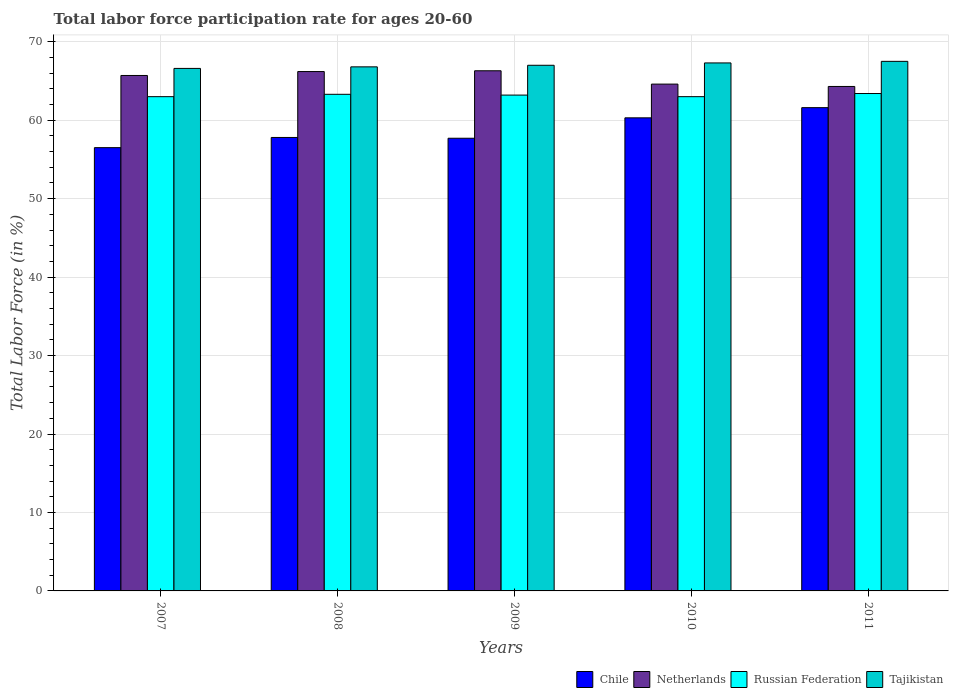How many different coloured bars are there?
Provide a succinct answer. 4. Are the number of bars per tick equal to the number of legend labels?
Your answer should be very brief. Yes. Are the number of bars on each tick of the X-axis equal?
Provide a succinct answer. Yes. What is the labor force participation rate in Netherlands in 2008?
Offer a very short reply. 66.2. Across all years, what is the maximum labor force participation rate in Chile?
Your answer should be compact. 61.6. Across all years, what is the minimum labor force participation rate in Tajikistan?
Give a very brief answer. 66.6. In which year was the labor force participation rate in Russian Federation maximum?
Give a very brief answer. 2011. In which year was the labor force participation rate in Netherlands minimum?
Offer a terse response. 2011. What is the total labor force participation rate in Netherlands in the graph?
Provide a succinct answer. 327.1. What is the difference between the labor force participation rate in Chile in 2010 and that in 2011?
Ensure brevity in your answer.  -1.3. What is the difference between the labor force participation rate in Netherlands in 2007 and the labor force participation rate in Chile in 2008?
Ensure brevity in your answer.  7.9. What is the average labor force participation rate in Russian Federation per year?
Offer a terse response. 63.18. In the year 2007, what is the difference between the labor force participation rate in Netherlands and labor force participation rate in Tajikistan?
Your response must be concise. -0.9. In how many years, is the labor force participation rate in Netherlands greater than 32 %?
Give a very brief answer. 5. What is the ratio of the labor force participation rate in Netherlands in 2007 to that in 2008?
Offer a very short reply. 0.99. What is the difference between the highest and the second highest labor force participation rate in Chile?
Keep it short and to the point. 1.3. In how many years, is the labor force participation rate in Russian Federation greater than the average labor force participation rate in Russian Federation taken over all years?
Offer a very short reply. 3. Is it the case that in every year, the sum of the labor force participation rate in Chile and labor force participation rate in Tajikistan is greater than the sum of labor force participation rate in Russian Federation and labor force participation rate in Netherlands?
Make the answer very short. No. What does the 3rd bar from the left in 2011 represents?
Provide a succinct answer. Russian Federation. What does the 2nd bar from the right in 2008 represents?
Offer a terse response. Russian Federation. Is it the case that in every year, the sum of the labor force participation rate in Chile and labor force participation rate in Russian Federation is greater than the labor force participation rate in Tajikistan?
Your response must be concise. Yes. How many bars are there?
Keep it short and to the point. 20. Are all the bars in the graph horizontal?
Ensure brevity in your answer.  No. Are the values on the major ticks of Y-axis written in scientific E-notation?
Offer a terse response. No. Does the graph contain any zero values?
Provide a short and direct response. No. Where does the legend appear in the graph?
Your response must be concise. Bottom right. How many legend labels are there?
Keep it short and to the point. 4. How are the legend labels stacked?
Provide a succinct answer. Horizontal. What is the title of the graph?
Make the answer very short. Total labor force participation rate for ages 20-60. Does "Equatorial Guinea" appear as one of the legend labels in the graph?
Offer a very short reply. No. What is the label or title of the X-axis?
Ensure brevity in your answer.  Years. What is the Total Labor Force (in %) in Chile in 2007?
Provide a succinct answer. 56.5. What is the Total Labor Force (in %) in Netherlands in 2007?
Keep it short and to the point. 65.7. What is the Total Labor Force (in %) of Tajikistan in 2007?
Your answer should be compact. 66.6. What is the Total Labor Force (in %) of Chile in 2008?
Offer a terse response. 57.8. What is the Total Labor Force (in %) of Netherlands in 2008?
Give a very brief answer. 66.2. What is the Total Labor Force (in %) of Russian Federation in 2008?
Make the answer very short. 63.3. What is the Total Labor Force (in %) of Tajikistan in 2008?
Make the answer very short. 66.8. What is the Total Labor Force (in %) of Chile in 2009?
Offer a terse response. 57.7. What is the Total Labor Force (in %) in Netherlands in 2009?
Offer a terse response. 66.3. What is the Total Labor Force (in %) in Russian Federation in 2009?
Provide a succinct answer. 63.2. What is the Total Labor Force (in %) of Tajikistan in 2009?
Ensure brevity in your answer.  67. What is the Total Labor Force (in %) of Chile in 2010?
Offer a terse response. 60.3. What is the Total Labor Force (in %) of Netherlands in 2010?
Provide a succinct answer. 64.6. What is the Total Labor Force (in %) of Tajikistan in 2010?
Your answer should be very brief. 67.3. What is the Total Labor Force (in %) of Chile in 2011?
Make the answer very short. 61.6. What is the Total Labor Force (in %) of Netherlands in 2011?
Keep it short and to the point. 64.3. What is the Total Labor Force (in %) of Russian Federation in 2011?
Your answer should be very brief. 63.4. What is the Total Labor Force (in %) in Tajikistan in 2011?
Give a very brief answer. 67.5. Across all years, what is the maximum Total Labor Force (in %) of Chile?
Ensure brevity in your answer.  61.6. Across all years, what is the maximum Total Labor Force (in %) in Netherlands?
Ensure brevity in your answer.  66.3. Across all years, what is the maximum Total Labor Force (in %) of Russian Federation?
Provide a short and direct response. 63.4. Across all years, what is the maximum Total Labor Force (in %) in Tajikistan?
Keep it short and to the point. 67.5. Across all years, what is the minimum Total Labor Force (in %) of Chile?
Offer a terse response. 56.5. Across all years, what is the minimum Total Labor Force (in %) in Netherlands?
Give a very brief answer. 64.3. Across all years, what is the minimum Total Labor Force (in %) of Russian Federation?
Your response must be concise. 63. Across all years, what is the minimum Total Labor Force (in %) of Tajikistan?
Your answer should be compact. 66.6. What is the total Total Labor Force (in %) in Chile in the graph?
Give a very brief answer. 293.9. What is the total Total Labor Force (in %) in Netherlands in the graph?
Offer a terse response. 327.1. What is the total Total Labor Force (in %) in Russian Federation in the graph?
Offer a very short reply. 315.9. What is the total Total Labor Force (in %) of Tajikistan in the graph?
Provide a short and direct response. 335.2. What is the difference between the Total Labor Force (in %) in Chile in 2007 and that in 2008?
Your answer should be very brief. -1.3. What is the difference between the Total Labor Force (in %) of Netherlands in 2007 and that in 2008?
Give a very brief answer. -0.5. What is the difference between the Total Labor Force (in %) of Tajikistan in 2007 and that in 2008?
Your answer should be compact. -0.2. What is the difference between the Total Labor Force (in %) of Netherlands in 2007 and that in 2009?
Your answer should be very brief. -0.6. What is the difference between the Total Labor Force (in %) of Tajikistan in 2007 and that in 2009?
Your answer should be very brief. -0.4. What is the difference between the Total Labor Force (in %) in Netherlands in 2007 and that in 2010?
Provide a short and direct response. 1.1. What is the difference between the Total Labor Force (in %) in Russian Federation in 2007 and that in 2010?
Make the answer very short. 0. What is the difference between the Total Labor Force (in %) of Russian Federation in 2008 and that in 2010?
Provide a succinct answer. 0.3. What is the difference between the Total Labor Force (in %) of Netherlands in 2009 and that in 2010?
Offer a very short reply. 1.7. What is the difference between the Total Labor Force (in %) in Tajikistan in 2009 and that in 2010?
Offer a very short reply. -0.3. What is the difference between the Total Labor Force (in %) in Netherlands in 2010 and that in 2011?
Offer a very short reply. 0.3. What is the difference between the Total Labor Force (in %) in Tajikistan in 2010 and that in 2011?
Offer a very short reply. -0.2. What is the difference between the Total Labor Force (in %) in Chile in 2007 and the Total Labor Force (in %) in Tajikistan in 2008?
Ensure brevity in your answer.  -10.3. What is the difference between the Total Labor Force (in %) of Netherlands in 2007 and the Total Labor Force (in %) of Russian Federation in 2008?
Your answer should be very brief. 2.4. What is the difference between the Total Labor Force (in %) of Chile in 2007 and the Total Labor Force (in %) of Netherlands in 2009?
Make the answer very short. -9.8. What is the difference between the Total Labor Force (in %) of Chile in 2007 and the Total Labor Force (in %) of Russian Federation in 2009?
Your answer should be compact. -6.7. What is the difference between the Total Labor Force (in %) in Netherlands in 2007 and the Total Labor Force (in %) in Tajikistan in 2009?
Keep it short and to the point. -1.3. What is the difference between the Total Labor Force (in %) in Chile in 2007 and the Total Labor Force (in %) in Netherlands in 2010?
Make the answer very short. -8.1. What is the difference between the Total Labor Force (in %) of Chile in 2007 and the Total Labor Force (in %) of Tajikistan in 2010?
Provide a short and direct response. -10.8. What is the difference between the Total Labor Force (in %) in Netherlands in 2007 and the Total Labor Force (in %) in Tajikistan in 2010?
Provide a succinct answer. -1.6. What is the difference between the Total Labor Force (in %) of Chile in 2007 and the Total Labor Force (in %) of Russian Federation in 2011?
Offer a very short reply. -6.9. What is the difference between the Total Labor Force (in %) in Netherlands in 2007 and the Total Labor Force (in %) in Russian Federation in 2011?
Provide a succinct answer. 2.3. What is the difference between the Total Labor Force (in %) in Netherlands in 2007 and the Total Labor Force (in %) in Tajikistan in 2011?
Offer a very short reply. -1.8. What is the difference between the Total Labor Force (in %) in Chile in 2008 and the Total Labor Force (in %) in Russian Federation in 2009?
Give a very brief answer. -5.4. What is the difference between the Total Labor Force (in %) in Netherlands in 2008 and the Total Labor Force (in %) in Tajikistan in 2009?
Give a very brief answer. -0.8. What is the difference between the Total Labor Force (in %) of Russian Federation in 2008 and the Total Labor Force (in %) of Tajikistan in 2009?
Offer a terse response. -3.7. What is the difference between the Total Labor Force (in %) in Chile in 2008 and the Total Labor Force (in %) in Netherlands in 2010?
Offer a terse response. -6.8. What is the difference between the Total Labor Force (in %) in Chile in 2008 and the Total Labor Force (in %) in Tajikistan in 2010?
Give a very brief answer. -9.5. What is the difference between the Total Labor Force (in %) in Netherlands in 2008 and the Total Labor Force (in %) in Russian Federation in 2010?
Your answer should be compact. 3.2. What is the difference between the Total Labor Force (in %) in Chile in 2008 and the Total Labor Force (in %) in Netherlands in 2011?
Provide a succinct answer. -6.5. What is the difference between the Total Labor Force (in %) of Chile in 2008 and the Total Labor Force (in %) of Russian Federation in 2011?
Your response must be concise. -5.6. What is the difference between the Total Labor Force (in %) of Chile in 2008 and the Total Labor Force (in %) of Tajikistan in 2011?
Your response must be concise. -9.7. What is the difference between the Total Labor Force (in %) of Netherlands in 2008 and the Total Labor Force (in %) of Russian Federation in 2011?
Your response must be concise. 2.8. What is the difference between the Total Labor Force (in %) in Netherlands in 2008 and the Total Labor Force (in %) in Tajikistan in 2011?
Provide a short and direct response. -1.3. What is the difference between the Total Labor Force (in %) in Russian Federation in 2008 and the Total Labor Force (in %) in Tajikistan in 2011?
Keep it short and to the point. -4.2. What is the difference between the Total Labor Force (in %) in Netherlands in 2009 and the Total Labor Force (in %) in Russian Federation in 2010?
Provide a short and direct response. 3.3. What is the difference between the Total Labor Force (in %) in Russian Federation in 2009 and the Total Labor Force (in %) in Tajikistan in 2010?
Provide a short and direct response. -4.1. What is the difference between the Total Labor Force (in %) in Chile in 2009 and the Total Labor Force (in %) in Russian Federation in 2011?
Ensure brevity in your answer.  -5.7. What is the difference between the Total Labor Force (in %) of Chile in 2009 and the Total Labor Force (in %) of Tajikistan in 2011?
Keep it short and to the point. -9.8. What is the difference between the Total Labor Force (in %) of Netherlands in 2009 and the Total Labor Force (in %) of Tajikistan in 2011?
Provide a short and direct response. -1.2. What is the difference between the Total Labor Force (in %) in Netherlands in 2010 and the Total Labor Force (in %) in Tajikistan in 2011?
Ensure brevity in your answer.  -2.9. What is the difference between the Total Labor Force (in %) of Russian Federation in 2010 and the Total Labor Force (in %) of Tajikistan in 2011?
Provide a short and direct response. -4.5. What is the average Total Labor Force (in %) in Chile per year?
Provide a succinct answer. 58.78. What is the average Total Labor Force (in %) in Netherlands per year?
Offer a terse response. 65.42. What is the average Total Labor Force (in %) in Russian Federation per year?
Make the answer very short. 63.18. What is the average Total Labor Force (in %) in Tajikistan per year?
Your answer should be very brief. 67.04. In the year 2007, what is the difference between the Total Labor Force (in %) in Chile and Total Labor Force (in %) in Netherlands?
Your answer should be compact. -9.2. In the year 2007, what is the difference between the Total Labor Force (in %) in Chile and Total Labor Force (in %) in Tajikistan?
Your answer should be very brief. -10.1. In the year 2007, what is the difference between the Total Labor Force (in %) of Netherlands and Total Labor Force (in %) of Tajikistan?
Keep it short and to the point. -0.9. In the year 2008, what is the difference between the Total Labor Force (in %) in Chile and Total Labor Force (in %) in Netherlands?
Your answer should be compact. -8.4. In the year 2008, what is the difference between the Total Labor Force (in %) in Netherlands and Total Labor Force (in %) in Russian Federation?
Give a very brief answer. 2.9. In the year 2008, what is the difference between the Total Labor Force (in %) in Netherlands and Total Labor Force (in %) in Tajikistan?
Keep it short and to the point. -0.6. In the year 2008, what is the difference between the Total Labor Force (in %) in Russian Federation and Total Labor Force (in %) in Tajikistan?
Provide a succinct answer. -3.5. In the year 2009, what is the difference between the Total Labor Force (in %) of Chile and Total Labor Force (in %) of Netherlands?
Your response must be concise. -8.6. In the year 2009, what is the difference between the Total Labor Force (in %) of Chile and Total Labor Force (in %) of Tajikistan?
Offer a very short reply. -9.3. In the year 2009, what is the difference between the Total Labor Force (in %) in Netherlands and Total Labor Force (in %) in Russian Federation?
Offer a terse response. 3.1. In the year 2010, what is the difference between the Total Labor Force (in %) in Chile and Total Labor Force (in %) in Netherlands?
Keep it short and to the point. -4.3. In the year 2010, what is the difference between the Total Labor Force (in %) in Netherlands and Total Labor Force (in %) in Russian Federation?
Provide a short and direct response. 1.6. In the year 2010, what is the difference between the Total Labor Force (in %) of Netherlands and Total Labor Force (in %) of Tajikistan?
Provide a short and direct response. -2.7. In the year 2010, what is the difference between the Total Labor Force (in %) in Russian Federation and Total Labor Force (in %) in Tajikistan?
Offer a terse response. -4.3. In the year 2011, what is the difference between the Total Labor Force (in %) in Chile and Total Labor Force (in %) in Netherlands?
Make the answer very short. -2.7. In the year 2011, what is the difference between the Total Labor Force (in %) in Chile and Total Labor Force (in %) in Tajikistan?
Ensure brevity in your answer.  -5.9. In the year 2011, what is the difference between the Total Labor Force (in %) in Netherlands and Total Labor Force (in %) in Russian Federation?
Ensure brevity in your answer.  0.9. What is the ratio of the Total Labor Force (in %) in Chile in 2007 to that in 2008?
Keep it short and to the point. 0.98. What is the ratio of the Total Labor Force (in %) of Netherlands in 2007 to that in 2008?
Provide a short and direct response. 0.99. What is the ratio of the Total Labor Force (in %) in Russian Federation in 2007 to that in 2008?
Make the answer very short. 1. What is the ratio of the Total Labor Force (in %) of Chile in 2007 to that in 2009?
Provide a succinct answer. 0.98. What is the ratio of the Total Labor Force (in %) of Tajikistan in 2007 to that in 2009?
Offer a very short reply. 0.99. What is the ratio of the Total Labor Force (in %) in Chile in 2007 to that in 2010?
Your answer should be very brief. 0.94. What is the ratio of the Total Labor Force (in %) of Russian Federation in 2007 to that in 2010?
Your answer should be very brief. 1. What is the ratio of the Total Labor Force (in %) of Chile in 2007 to that in 2011?
Provide a succinct answer. 0.92. What is the ratio of the Total Labor Force (in %) of Netherlands in 2007 to that in 2011?
Ensure brevity in your answer.  1.02. What is the ratio of the Total Labor Force (in %) in Tajikistan in 2007 to that in 2011?
Keep it short and to the point. 0.99. What is the ratio of the Total Labor Force (in %) of Chile in 2008 to that in 2009?
Your response must be concise. 1. What is the ratio of the Total Labor Force (in %) in Netherlands in 2008 to that in 2009?
Offer a very short reply. 1. What is the ratio of the Total Labor Force (in %) of Russian Federation in 2008 to that in 2009?
Keep it short and to the point. 1. What is the ratio of the Total Labor Force (in %) of Chile in 2008 to that in 2010?
Make the answer very short. 0.96. What is the ratio of the Total Labor Force (in %) in Netherlands in 2008 to that in 2010?
Your answer should be very brief. 1.02. What is the ratio of the Total Labor Force (in %) in Chile in 2008 to that in 2011?
Your response must be concise. 0.94. What is the ratio of the Total Labor Force (in %) of Netherlands in 2008 to that in 2011?
Keep it short and to the point. 1.03. What is the ratio of the Total Labor Force (in %) of Russian Federation in 2008 to that in 2011?
Provide a short and direct response. 1. What is the ratio of the Total Labor Force (in %) of Chile in 2009 to that in 2010?
Offer a very short reply. 0.96. What is the ratio of the Total Labor Force (in %) of Netherlands in 2009 to that in 2010?
Provide a succinct answer. 1.03. What is the ratio of the Total Labor Force (in %) of Russian Federation in 2009 to that in 2010?
Ensure brevity in your answer.  1. What is the ratio of the Total Labor Force (in %) of Chile in 2009 to that in 2011?
Your answer should be very brief. 0.94. What is the ratio of the Total Labor Force (in %) of Netherlands in 2009 to that in 2011?
Give a very brief answer. 1.03. What is the ratio of the Total Labor Force (in %) in Russian Federation in 2009 to that in 2011?
Your answer should be compact. 1. What is the ratio of the Total Labor Force (in %) in Chile in 2010 to that in 2011?
Provide a short and direct response. 0.98. What is the ratio of the Total Labor Force (in %) of Netherlands in 2010 to that in 2011?
Offer a terse response. 1. What is the difference between the highest and the second highest Total Labor Force (in %) in Tajikistan?
Provide a short and direct response. 0.2. What is the difference between the highest and the lowest Total Labor Force (in %) of Chile?
Provide a succinct answer. 5.1. What is the difference between the highest and the lowest Total Labor Force (in %) in Netherlands?
Your answer should be very brief. 2. What is the difference between the highest and the lowest Total Labor Force (in %) in Tajikistan?
Keep it short and to the point. 0.9. 